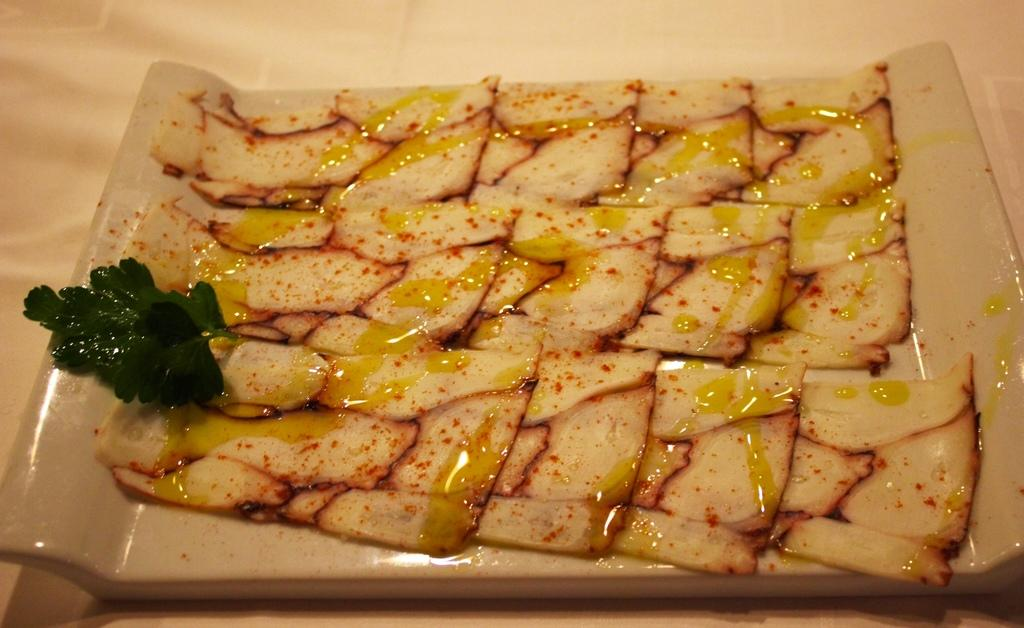What is present on the tray in the image? There are: There are food items on a tray in the image. Can you describe the arrangement of the food items on the tray? The provided facts do not give enough information to describe the arrangement of the food items on the tray. What type of surface is the tray placed on? The provided facts do not give enough information to determine the surface the tray is placed on. What is the flavor of the club in the image? There is no club present in the image, so it is not possible to determine its flavor. 